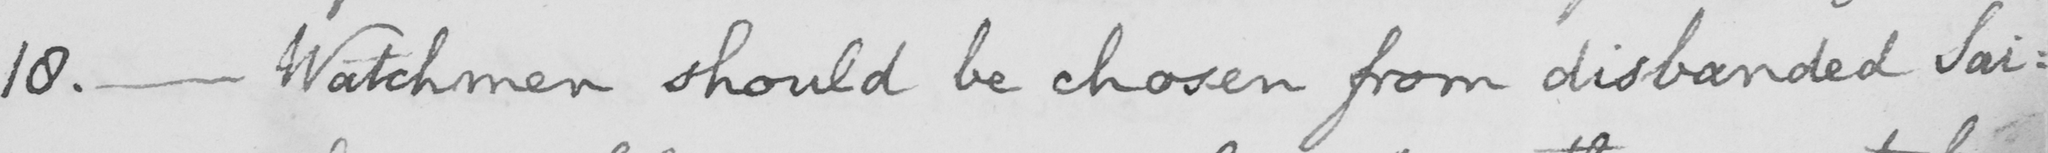Please provide the text content of this handwritten line. 18 .  _  Watchmen should be chosen from disbanded Sai : 